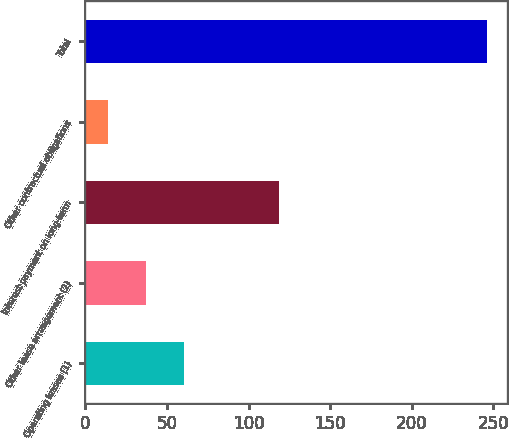<chart> <loc_0><loc_0><loc_500><loc_500><bar_chart><fcel>Operating leases (1)<fcel>Other lease arrangement (2)<fcel>Interest payment on long-term<fcel>Other contractual obligations<fcel>Total<nl><fcel>60.38<fcel>37.19<fcel>118.7<fcel>14<fcel>245.9<nl></chart> 